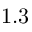<formula> <loc_0><loc_0><loc_500><loc_500>1 . 3</formula> 